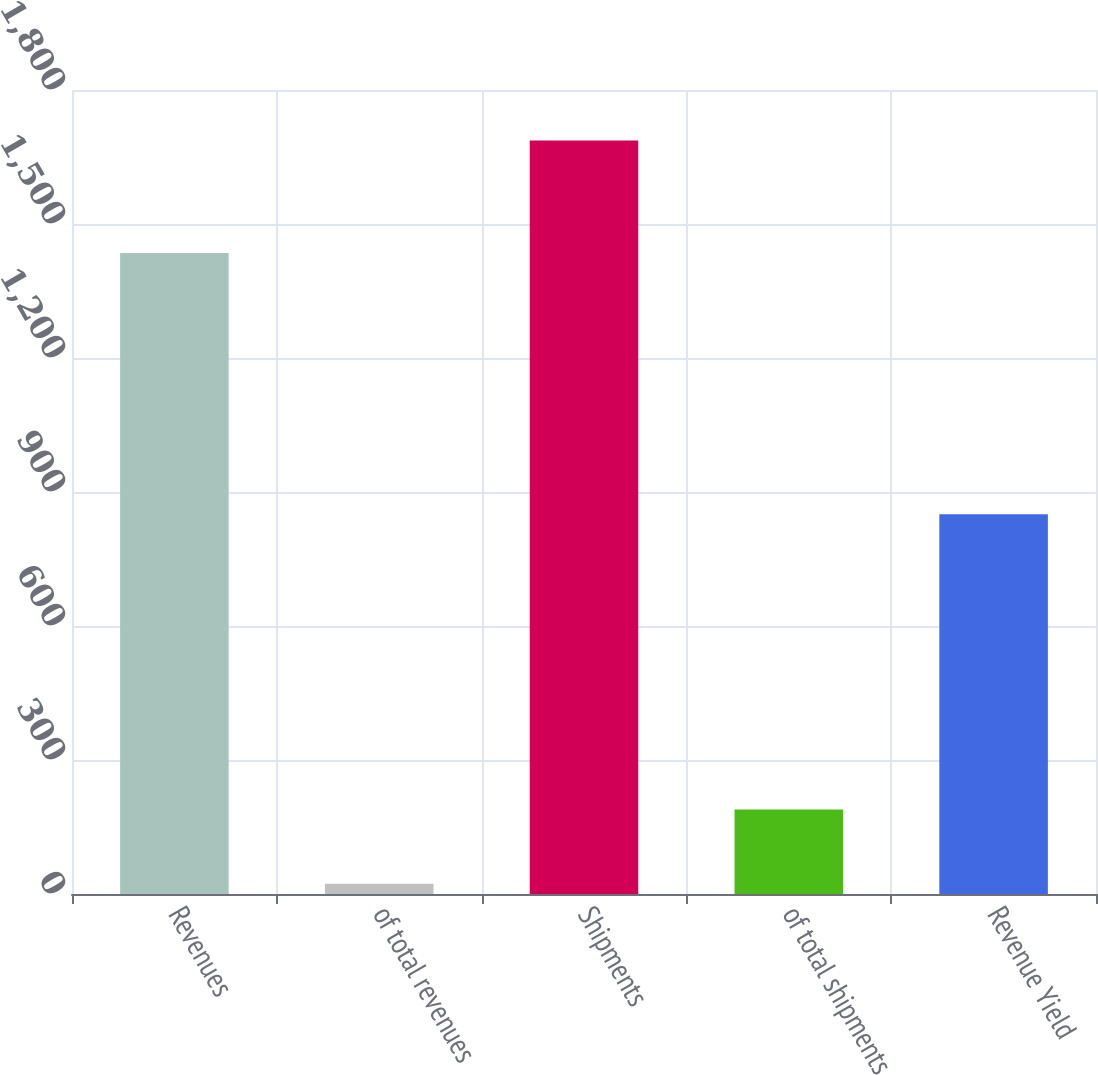Convert chart. <chart><loc_0><loc_0><loc_500><loc_500><bar_chart><fcel>Revenues<fcel>of total revenues<fcel>Shipments<fcel>of total shipments<fcel>Revenue Yield<nl><fcel>1435<fcel>23<fcel>1687<fcel>189.4<fcel>850<nl></chart> 